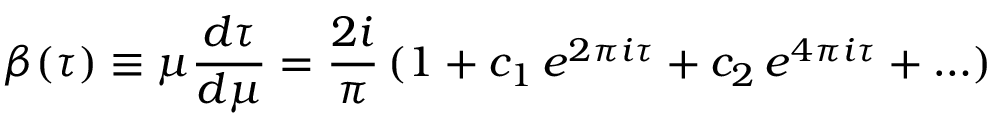Convert formula to latex. <formula><loc_0><loc_0><loc_500><loc_500>\beta ( \tau ) \equiv \mu { \frac { d \tau } { d \mu } } = { \frac { 2 i } { \pi } } \, ( 1 + c _ { 1 } \, e ^ { 2 \pi i \tau } + c _ { 2 } \, e ^ { 4 \pi i \tau } + \dots )</formula> 